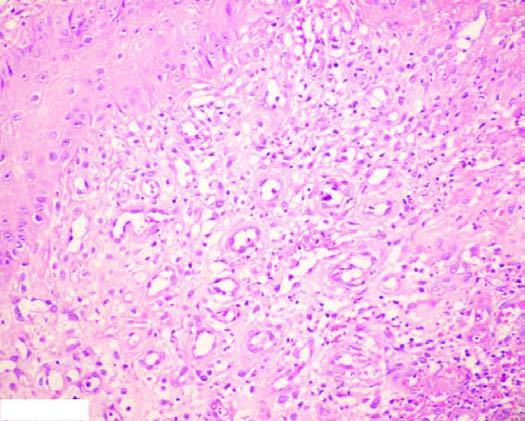what does ctive granulation tissue have?
Answer the question using a single word or phrase. Inflammatory cell infiltra 